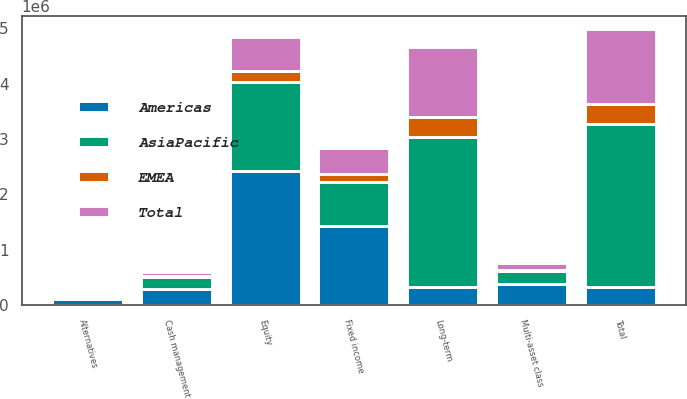Convert chart. <chart><loc_0><loc_0><loc_500><loc_500><stacked_bar_chart><ecel><fcel>Equity<fcel>Fixed income<fcel>Multi-asset class<fcel>Alternatives<fcel>Long-term<fcel>Cash management<fcel>Total<nl><fcel>AsiaPacific<fcel>1.61078e+06<fcel>807722<fcel>233441<fcel>59644<fcel>2.71158e+06<fcel>216079<fcel>2.93503e+06<nl><fcel>Total<fcel>622744<fcel>485388<fcel>120362<fcel>35855<fcel>1.26435e+06<fcel>80962<fcel>1.34816e+06<nl><fcel>EMEA<fcel>190252<fcel>129258<fcel>22533<fcel>17340<fcel>359383<fcel>2843<fcel>362226<nl><fcel>Americas<fcel>2.42377e+06<fcel>1.42237e+06<fcel>376336<fcel>112839<fcel>329634<fcel>299884<fcel>329634<nl></chart> 